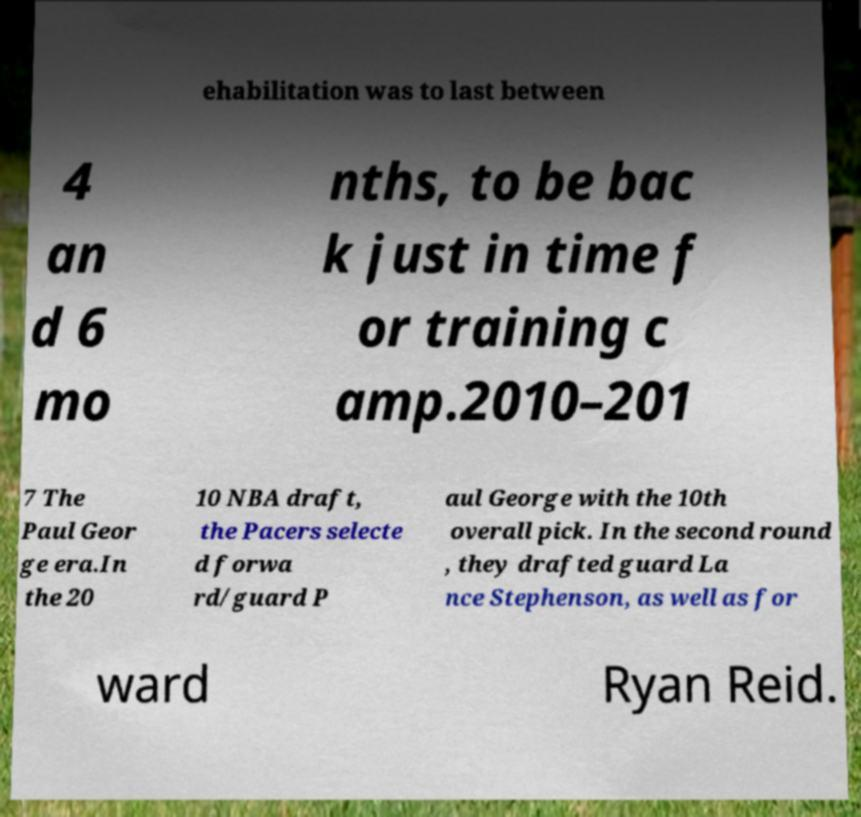For documentation purposes, I need the text within this image transcribed. Could you provide that? ehabilitation was to last between 4 an d 6 mo nths, to be bac k just in time f or training c amp.2010–201 7 The Paul Geor ge era.In the 20 10 NBA draft, the Pacers selecte d forwa rd/guard P aul George with the 10th overall pick. In the second round , they drafted guard La nce Stephenson, as well as for ward Ryan Reid. 